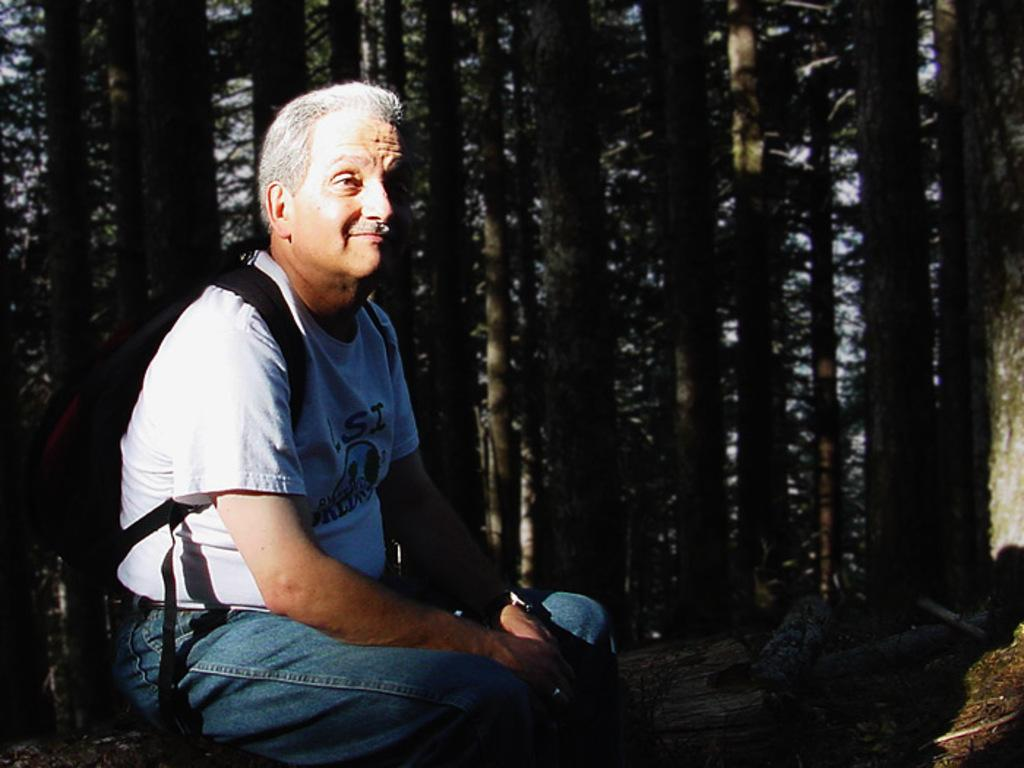Who is the main subject in the picture? There is an old man in the picture. What is the old man wearing? The old man is wearing a white t-shirt. What is the old man doing in the picture? The old man is cutting something and posing for the camera. What can be seen in the background of the picture? There are tall trees in the background of the picture. How many friends are visible in the picture? There are no friends visible in the picture; it only features the old man. Is the old man sleeping in the picture? No, the old man is not sleeping in the picture; he is cutting something and posing for the camera. What letter is the old man holding in the picture? There is no letter present in the picture; the old man is cutting something. 